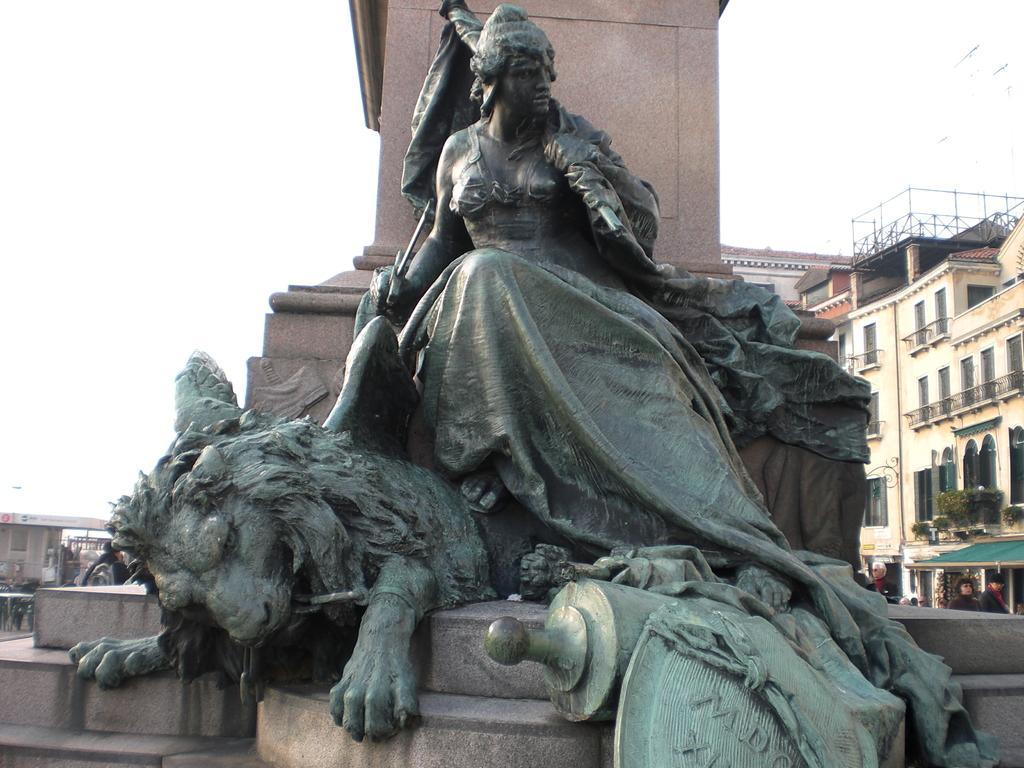In one or two sentences, can you explain what this image depicts? In the background we can see the sky, buildings, windows, plants, people, pillar and few objects. In this picture we can see the statue of a woman and an animal on a pedestal. 